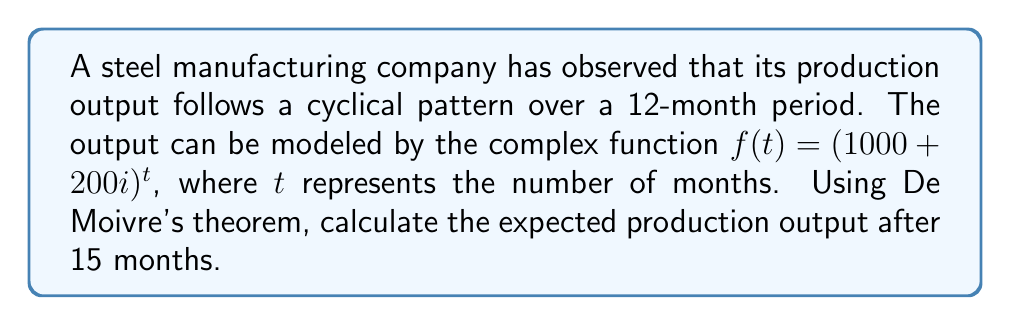What is the answer to this math problem? Let's approach this step-by-step:

1) First, we need to express the complex number in polar form:
   $1000 + 200i = r(\cos\theta + i\sin\theta)$

2) Calculate $r$:
   $r = \sqrt{1000^2 + 200^2} = \sqrt{1,040,000} = 1020$

3) Calculate $\theta$:
   $\theta = \tan^{-1}(\frac{200}{1000}) \approx 0.1974$ radians

4) Now we have: $1000 + 200i = 1020(\cos 0.1974 + i\sin 0.1974)$

5) Using De Moivre's theorem, we can write:
   $f(t) = (1000 + 200i)^t = 1020^t(\cos(0.1974t) + i\sin(0.1974t))$

6) For $t = 15$:
   $f(15) = 1020^{15}(\cos(2.961) + i\sin(2.961))$

7) Calculate $1020^{15}$:
   $1020^{15} \approx 1.2679 \times 10^{45}$

8) Calculate $\cos(2.961)$ and $\sin(2.961)$:
   $\cos(2.961) \approx -0.9839$
   $\sin(2.961) \approx 0.1786$

9) Therefore:
   $f(15) \approx (1.2679 \times 10^{45})(-0.9839 + 0.1786i)$

10) The real part represents the actual production output:
    $\text{Output} = 1.2679 \times 10^{45} \times (-0.9839) \approx -1.2475 \times 10^{45}$
Answer: $-1.2475 \times 10^{45}$ units 